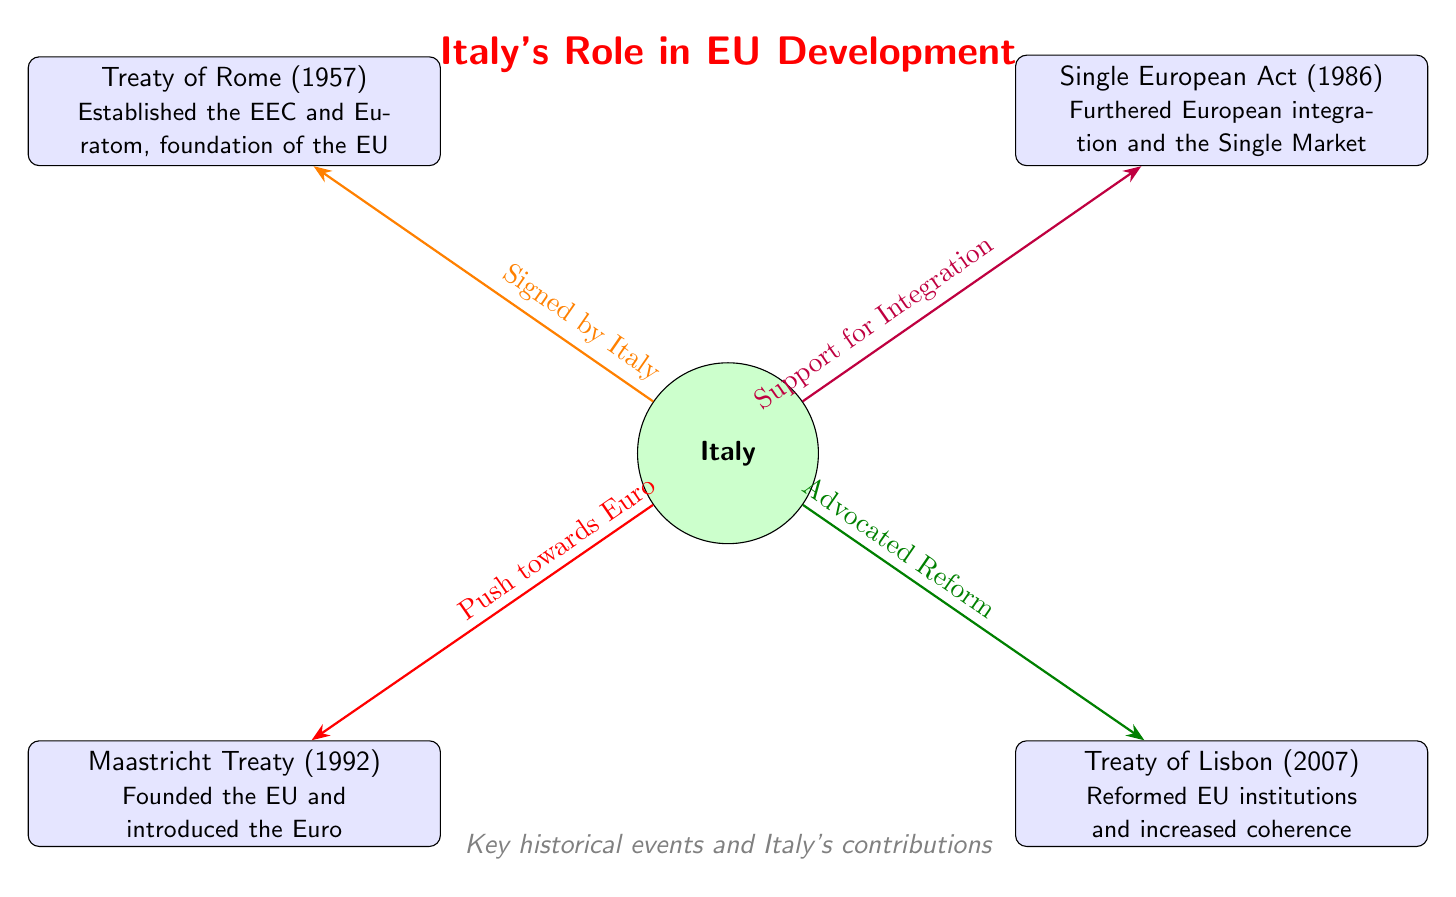What is the first treaty represented in the diagram? The first treaty in the diagram is located at the top left node, which is the Treaty of Rome, signed in 1957.
Answer: Treaty of Rome Which treaty introduced the Euro? The Maastricht Treaty is presented at the bottom left node. It specifically mentions the introduction of the Euro, making it the answer.
Answer: Maastricht Treaty How many treaties are depicted in the diagram? The diagram displays a total of four treaties, each represented as a distinct event node connected to Italy.
Answer: 4 What significant action is associated with the Treaty of Lisbon? The Treaty of Lisbon, shown in the bottom right node, is associated with advocating reform, as indicated by the connection from Italy to this treaty.
Answer: Advocated Reform Which treaty is connected to Italy with the description "Support for Integration"? Looking at the connections, the Single European Act (1986) node is directly linked to Italy with that exact description.
Answer: Single European Act Which treaty established the EEC and Euratom? The Treaty of Rome is stated at the top left, mentioning its establishment of EEC and Euratom, and thus is the answer.
Answer: Treaty of Rome What role does Italy play regarding the Maastricht Treaty? The Maastricht Treaty has a connection to Italy labeled "Push towards Euro," indicating Italy's role in promoting Euro introduction through this treaty.
Answer: Push towards Euro Which treaty is the last one depicted in the diagram? The last treaty is the Treaty of Lisbon, positioned at the bottom right, showing that it is the final represented event in the diagram.
Answer: Treaty of Lisbon How does Italy's role relate to the Single European Act? Italy's connection to the Single European Act is described as "Support for Integration," indicating Italy's backing for continued integration efforts in Europe.
Answer: Support for Integration 